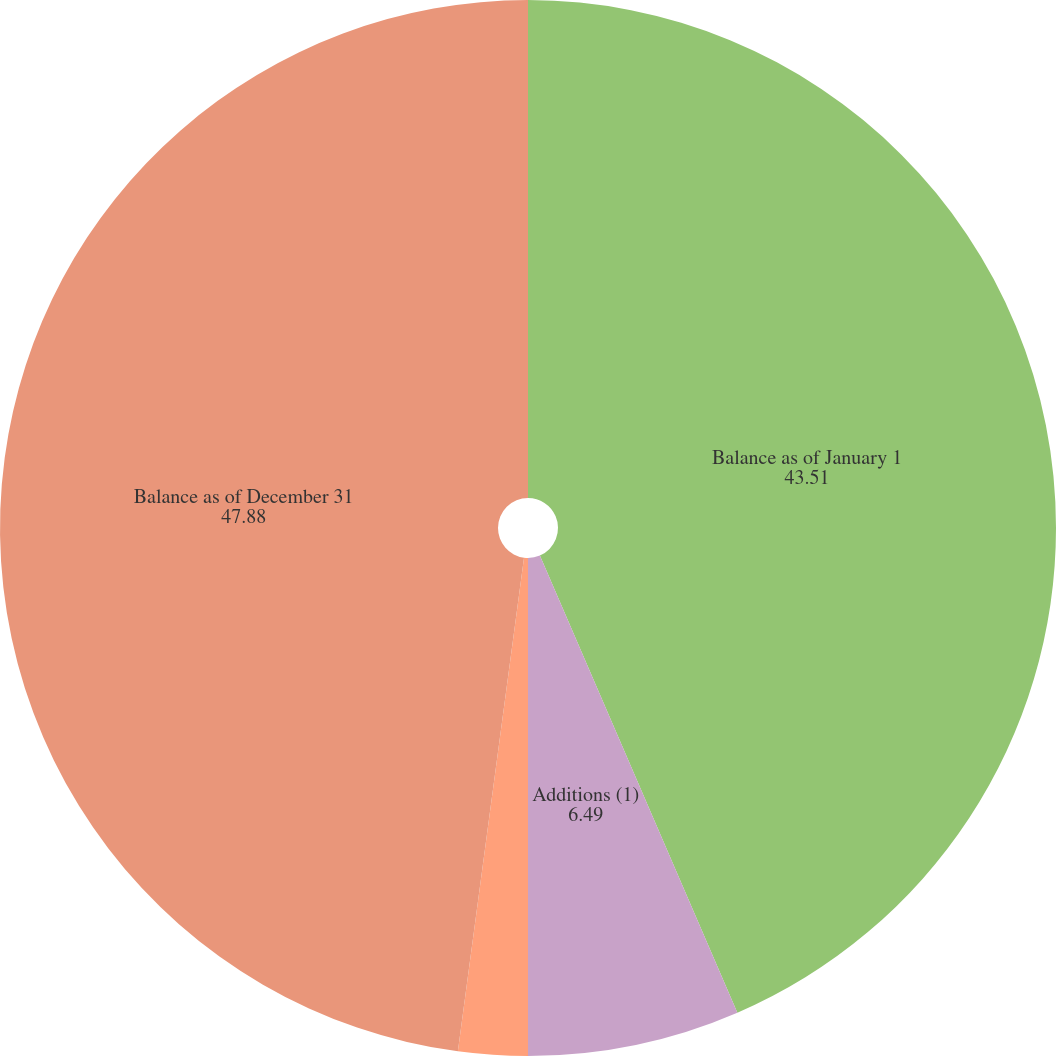<chart> <loc_0><loc_0><loc_500><loc_500><pie_chart><fcel>Balance as of January 1<fcel>Additions (1)<fcel>Foreign currency translation<fcel>Balance as of December 31<nl><fcel>43.51%<fcel>6.49%<fcel>2.12%<fcel>47.88%<nl></chart> 